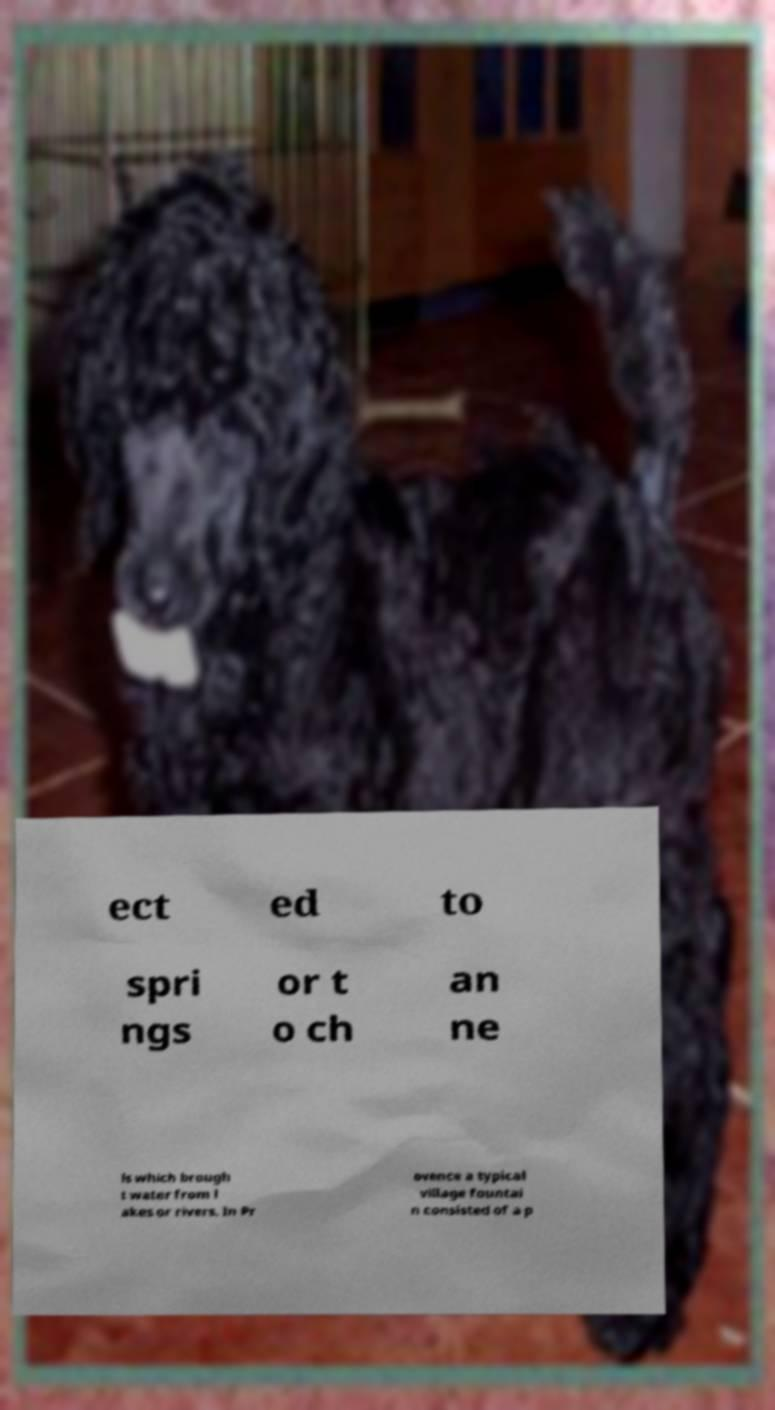Can you accurately transcribe the text from the provided image for me? ect ed to spri ngs or t o ch an ne ls which brough t water from l akes or rivers. In Pr ovence a typical village fountai n consisted of a p 